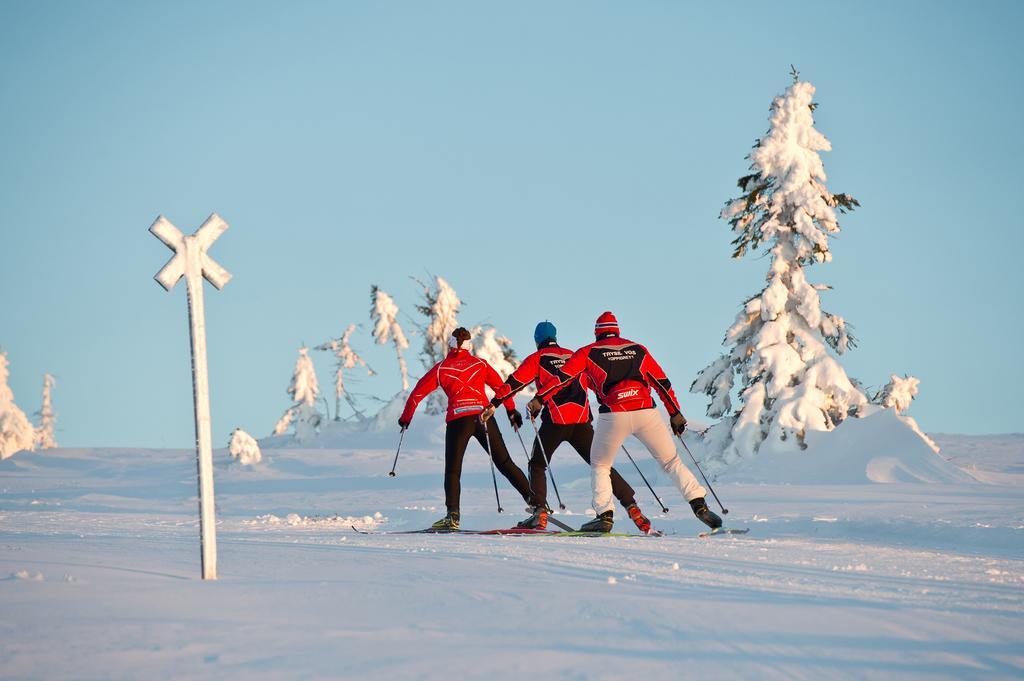Can you describe this image briefly? This picture shows three people skiing on the snow and we see tree and few plants and a pole. They wore caps on their heads and red color jackets and we see a cloudy sky. 